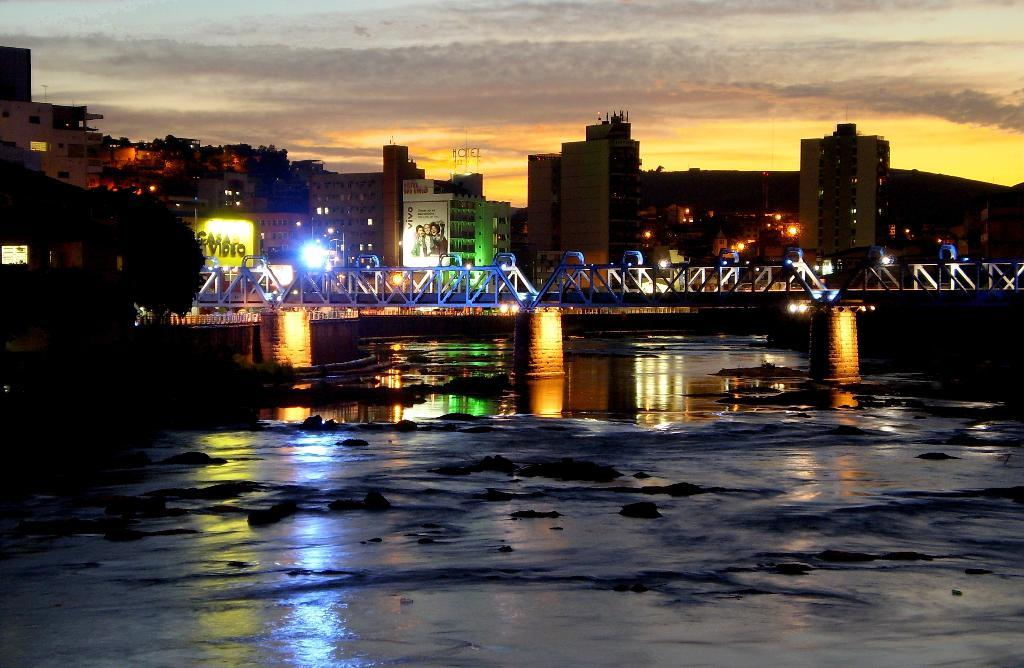What is present in the image that is related to water? There is water in the image. What structure can be seen crossing over the water? There is a bridge in the image. What can be seen in the distance behind the bridge? There are buildings in the background of the image. What is the condition of the sky in the image? The sky is clear and visible in the image. What type of cart is being pushed across the bridge in the image? There is no cart or pushing action present in the image. 